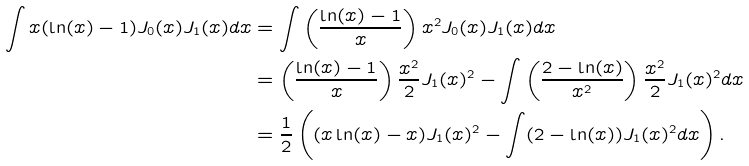Convert formula to latex. <formula><loc_0><loc_0><loc_500><loc_500>\int x ( \ln ( x ) - 1 ) J _ { 0 } ( x ) J _ { 1 } ( x ) d x & = \int \left ( \frac { \ln ( x ) - 1 } { x } \right ) x ^ { 2 } J _ { 0 } ( x ) J _ { 1 } ( x ) d x \\ & = \left ( \frac { \ln ( x ) - 1 } { x } \right ) \frac { x ^ { 2 } } { 2 } J _ { 1 } ( x ) ^ { 2 } - \int \left ( \frac { 2 - \ln ( x ) } { x ^ { 2 } } \right ) \frac { x ^ { 2 } } { 2 } J _ { 1 } ( x ) ^ { 2 } d x \\ & = \frac { 1 } { 2 } \left ( ( x \ln ( x ) - x ) J _ { 1 } ( x ) ^ { 2 } - \int ( 2 - \ln ( x ) ) J _ { 1 } ( x ) ^ { 2 } d x \right ) . \\</formula> 